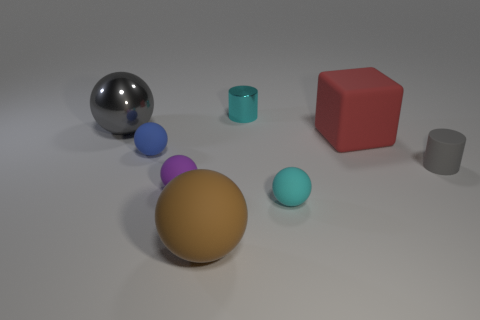Subtract all brown spheres. How many spheres are left? 4 Subtract all cyan spheres. How many spheres are left? 4 Subtract all yellow spheres. Subtract all blue blocks. How many spheres are left? 5 Add 2 small purple things. How many objects exist? 10 Subtract all balls. How many objects are left? 3 Add 6 purple matte things. How many purple matte things are left? 7 Add 1 small green metal cylinders. How many small green metal cylinders exist? 1 Subtract 0 blue cylinders. How many objects are left? 8 Subtract all balls. Subtract all tiny purple cylinders. How many objects are left? 3 